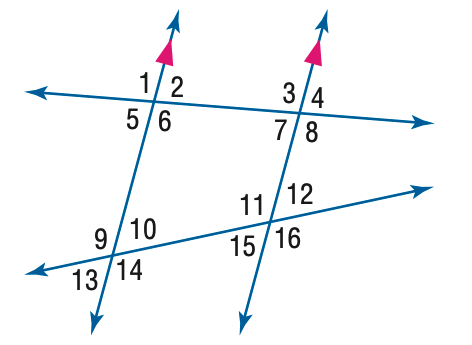Answer the mathemtical geometry problem and directly provide the correct option letter.
Question: In the figure, m \angle 3 = 110 and m \angle 12 = 55. Find the measure of \angle 10.
Choices: A: 55 B: 70 C: 110 D: 125 A 